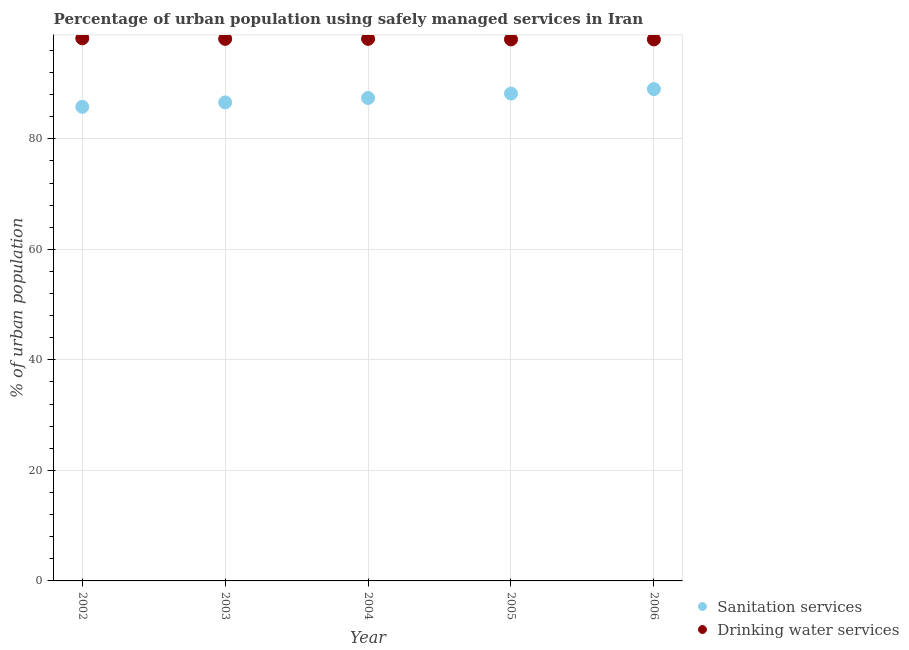Is the number of dotlines equal to the number of legend labels?
Offer a terse response. Yes. What is the percentage of urban population who used sanitation services in 2002?
Keep it short and to the point. 85.8. Across all years, what is the maximum percentage of urban population who used drinking water services?
Offer a terse response. 98.2. In which year was the percentage of urban population who used drinking water services maximum?
Keep it short and to the point. 2002. In which year was the percentage of urban population who used sanitation services minimum?
Your answer should be very brief. 2002. What is the total percentage of urban population who used sanitation services in the graph?
Provide a short and direct response. 437. What is the difference between the percentage of urban population who used drinking water services in 2002 and that in 2006?
Keep it short and to the point. 0.2. What is the difference between the percentage of urban population who used drinking water services in 2002 and the percentage of urban population who used sanitation services in 2004?
Your answer should be very brief. 10.8. What is the average percentage of urban population who used sanitation services per year?
Ensure brevity in your answer.  87.4. In the year 2002, what is the difference between the percentage of urban population who used drinking water services and percentage of urban population who used sanitation services?
Provide a short and direct response. 12.4. What is the ratio of the percentage of urban population who used drinking water services in 2004 to that in 2005?
Provide a succinct answer. 1. Is the percentage of urban population who used drinking water services in 2002 less than that in 2003?
Your response must be concise. No. What is the difference between the highest and the second highest percentage of urban population who used sanitation services?
Offer a terse response. 0.8. What is the difference between the highest and the lowest percentage of urban population who used drinking water services?
Your response must be concise. 0.2. In how many years, is the percentage of urban population who used sanitation services greater than the average percentage of urban population who used sanitation services taken over all years?
Provide a succinct answer. 3. Is the percentage of urban population who used drinking water services strictly less than the percentage of urban population who used sanitation services over the years?
Ensure brevity in your answer.  No. Are the values on the major ticks of Y-axis written in scientific E-notation?
Offer a very short reply. No. Does the graph contain any zero values?
Ensure brevity in your answer.  No. Does the graph contain grids?
Keep it short and to the point. Yes. How many legend labels are there?
Offer a very short reply. 2. What is the title of the graph?
Offer a terse response. Percentage of urban population using safely managed services in Iran. Does "Under-five" appear as one of the legend labels in the graph?
Ensure brevity in your answer.  No. What is the label or title of the Y-axis?
Your answer should be compact. % of urban population. What is the % of urban population in Sanitation services in 2002?
Provide a succinct answer. 85.8. What is the % of urban population in Drinking water services in 2002?
Provide a succinct answer. 98.2. What is the % of urban population of Sanitation services in 2003?
Ensure brevity in your answer.  86.6. What is the % of urban population in Drinking water services in 2003?
Give a very brief answer. 98.1. What is the % of urban population of Sanitation services in 2004?
Your answer should be very brief. 87.4. What is the % of urban population of Drinking water services in 2004?
Offer a very short reply. 98.1. What is the % of urban population in Sanitation services in 2005?
Offer a terse response. 88.2. What is the % of urban population of Drinking water services in 2005?
Provide a succinct answer. 98. What is the % of urban population of Sanitation services in 2006?
Your response must be concise. 89. What is the % of urban population in Drinking water services in 2006?
Offer a terse response. 98. Across all years, what is the maximum % of urban population in Sanitation services?
Offer a very short reply. 89. Across all years, what is the maximum % of urban population in Drinking water services?
Offer a terse response. 98.2. Across all years, what is the minimum % of urban population in Sanitation services?
Your answer should be compact. 85.8. Across all years, what is the minimum % of urban population of Drinking water services?
Offer a very short reply. 98. What is the total % of urban population in Sanitation services in the graph?
Provide a short and direct response. 437. What is the total % of urban population of Drinking water services in the graph?
Ensure brevity in your answer.  490.4. What is the difference between the % of urban population of Drinking water services in 2002 and that in 2003?
Your answer should be very brief. 0.1. What is the difference between the % of urban population in Sanitation services in 2002 and that in 2004?
Your response must be concise. -1.6. What is the difference between the % of urban population of Drinking water services in 2002 and that in 2005?
Your answer should be very brief. 0.2. What is the difference between the % of urban population in Sanitation services in 2003 and that in 2004?
Offer a very short reply. -0.8. What is the difference between the % of urban population of Drinking water services in 2003 and that in 2004?
Your response must be concise. 0. What is the difference between the % of urban population in Drinking water services in 2003 and that in 2006?
Provide a succinct answer. 0.1. What is the difference between the % of urban population of Sanitation services in 2004 and that in 2005?
Your response must be concise. -0.8. What is the difference between the % of urban population in Sanitation services in 2004 and that in 2006?
Ensure brevity in your answer.  -1.6. What is the difference between the % of urban population of Sanitation services in 2002 and the % of urban population of Drinking water services in 2003?
Provide a succinct answer. -12.3. What is the difference between the % of urban population in Sanitation services in 2003 and the % of urban population in Drinking water services in 2005?
Provide a short and direct response. -11.4. What is the difference between the % of urban population of Sanitation services in 2004 and the % of urban population of Drinking water services in 2006?
Ensure brevity in your answer.  -10.6. What is the average % of urban population of Sanitation services per year?
Your answer should be compact. 87.4. What is the average % of urban population in Drinking water services per year?
Make the answer very short. 98.08. In the year 2005, what is the difference between the % of urban population of Sanitation services and % of urban population of Drinking water services?
Offer a terse response. -9.8. In the year 2006, what is the difference between the % of urban population in Sanitation services and % of urban population in Drinking water services?
Offer a terse response. -9. What is the ratio of the % of urban population of Sanitation services in 2002 to that in 2003?
Provide a succinct answer. 0.99. What is the ratio of the % of urban population in Sanitation services in 2002 to that in 2004?
Make the answer very short. 0.98. What is the ratio of the % of urban population in Drinking water services in 2002 to that in 2004?
Provide a succinct answer. 1. What is the ratio of the % of urban population of Sanitation services in 2002 to that in 2005?
Offer a terse response. 0.97. What is the ratio of the % of urban population of Drinking water services in 2002 to that in 2006?
Your answer should be compact. 1. What is the ratio of the % of urban population of Sanitation services in 2003 to that in 2004?
Offer a terse response. 0.99. What is the ratio of the % of urban population in Sanitation services in 2003 to that in 2005?
Give a very brief answer. 0.98. What is the ratio of the % of urban population of Drinking water services in 2003 to that in 2005?
Give a very brief answer. 1. What is the ratio of the % of urban population of Sanitation services in 2003 to that in 2006?
Provide a succinct answer. 0.97. What is the ratio of the % of urban population of Sanitation services in 2004 to that in 2005?
Your answer should be very brief. 0.99. What is the ratio of the % of urban population of Sanitation services in 2004 to that in 2006?
Offer a terse response. 0.98. What is the ratio of the % of urban population of Sanitation services in 2005 to that in 2006?
Provide a succinct answer. 0.99. What is the difference between the highest and the second highest % of urban population of Drinking water services?
Offer a terse response. 0.1. What is the difference between the highest and the lowest % of urban population in Sanitation services?
Make the answer very short. 3.2. 